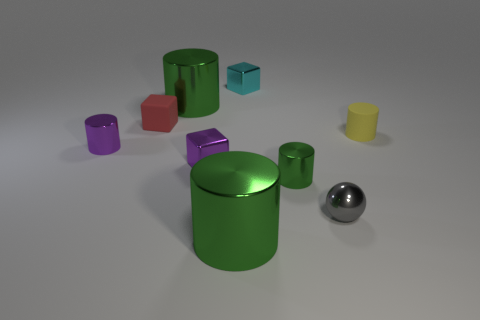Subtract all green cylinders. How many were subtracted if there are1green cylinders left? 2 Subtract all small cylinders. How many cylinders are left? 2 Subtract all yellow cylinders. How many cylinders are left? 4 Add 1 metal cylinders. How many objects exist? 10 Subtract all balls. How many objects are left? 8 Subtract 2 cylinders. How many cylinders are left? 3 Subtract all yellow blocks. Subtract all green spheres. How many blocks are left? 3 Subtract all blue spheres. How many red blocks are left? 1 Add 4 green shiny cylinders. How many green shiny cylinders are left? 7 Add 9 tiny metallic spheres. How many tiny metallic spheres exist? 10 